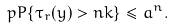<formula> <loc_0><loc_0><loc_500><loc_500>\ p P \{ \tau _ { r } ( y ) > n k \} \leq a ^ { n } .</formula> 